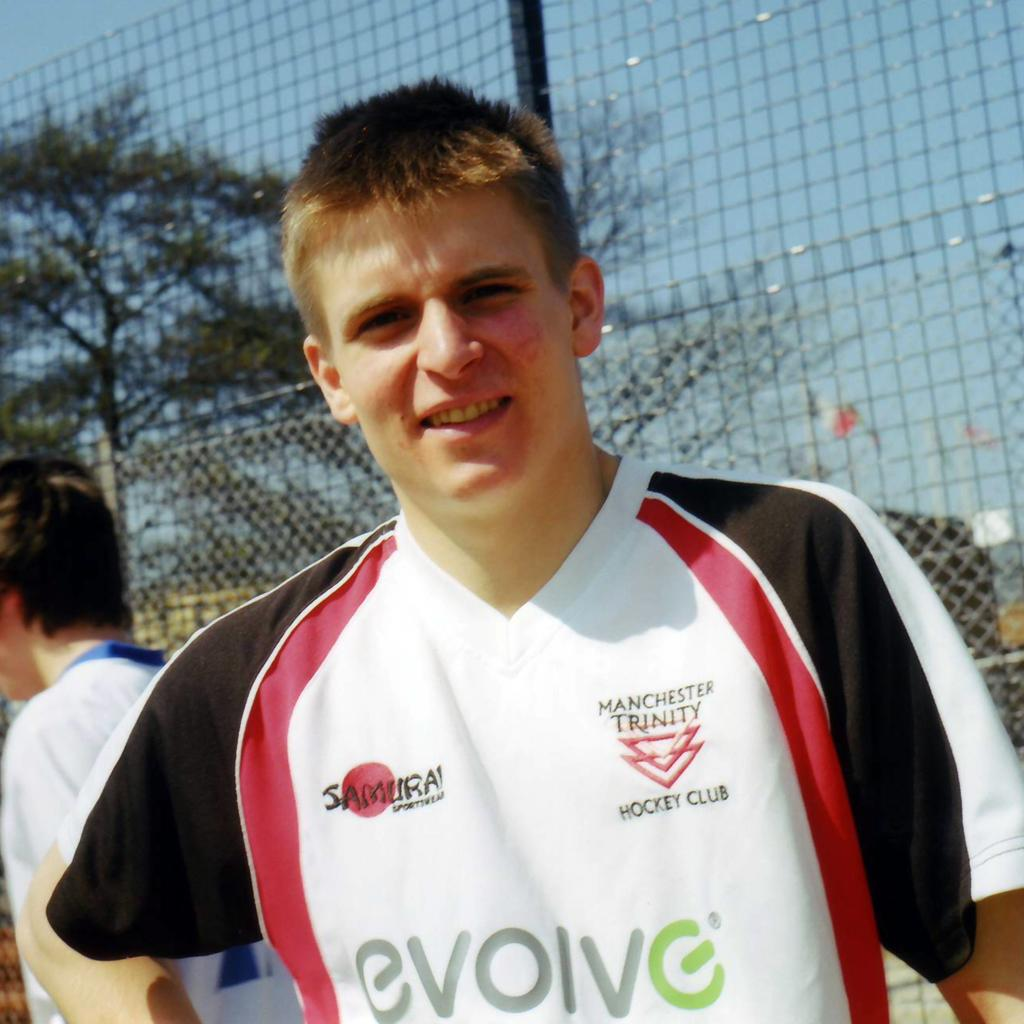Provide a one-sentence caption for the provided image. A picture of a hockey player from The Manchester Trinity Hockey Club. 